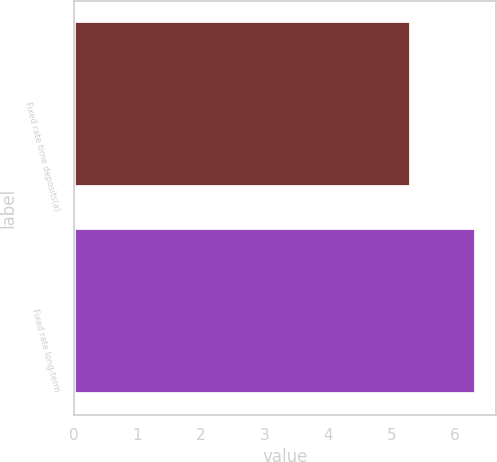Convert chart. <chart><loc_0><loc_0><loc_500><loc_500><bar_chart><fcel>Fixed rate time deposits(a)<fcel>Fixed rate long-term<nl><fcel>5.3<fcel>6.33<nl></chart> 